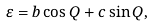Convert formula to latex. <formula><loc_0><loc_0><loc_500><loc_500>\varepsilon = b \cos Q + c \sin Q ,</formula> 